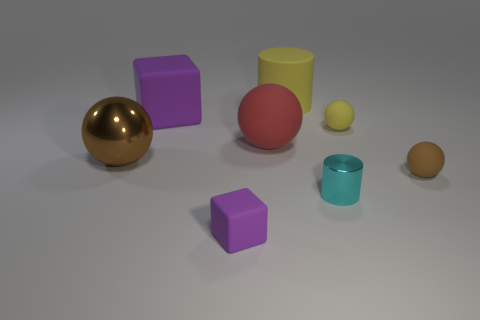Add 1 metal balls. How many objects exist? 9 Subtract all yellow matte spheres. How many spheres are left? 3 Subtract all brown blocks. How many brown balls are left? 2 Subtract all red spheres. How many spheres are left? 3 Subtract 0 brown cubes. How many objects are left? 8 Subtract all cylinders. How many objects are left? 6 Subtract 2 cylinders. How many cylinders are left? 0 Subtract all cyan balls. Subtract all purple cubes. How many balls are left? 4 Subtract all large things. Subtract all brown metal objects. How many objects are left? 3 Add 8 yellow balls. How many yellow balls are left? 9 